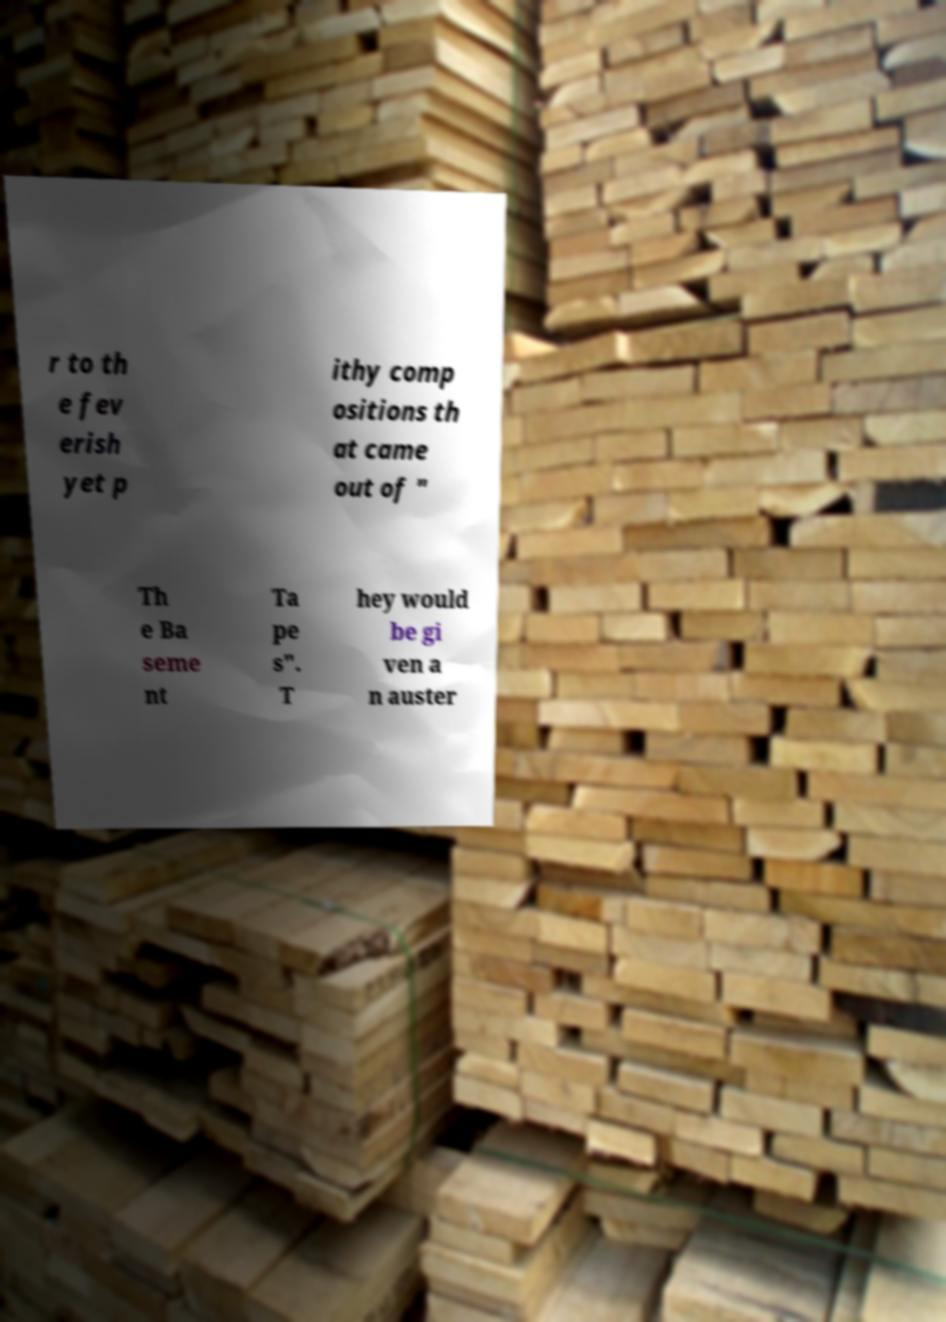Could you assist in decoding the text presented in this image and type it out clearly? r to th e fev erish yet p ithy comp ositions th at came out of " Th e Ba seme nt Ta pe s". T hey would be gi ven a n auster 